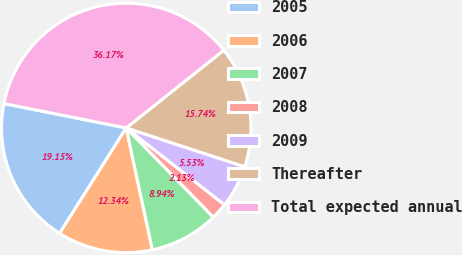Convert chart. <chart><loc_0><loc_0><loc_500><loc_500><pie_chart><fcel>2005<fcel>2006<fcel>2007<fcel>2008<fcel>2009<fcel>Thereafter<fcel>Total expected annual<nl><fcel>19.15%<fcel>12.34%<fcel>8.94%<fcel>2.13%<fcel>5.53%<fcel>15.74%<fcel>36.17%<nl></chart> 